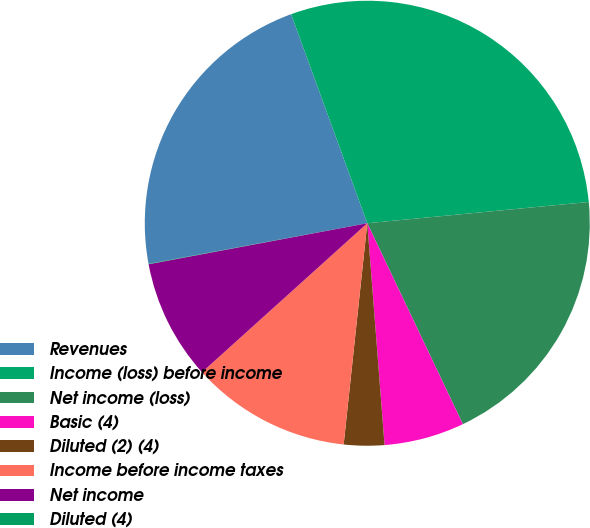Convert chart. <chart><loc_0><loc_0><loc_500><loc_500><pie_chart><fcel>Revenues<fcel>Income (loss) before income<fcel>Net income (loss)<fcel>Basic (4)<fcel>Diluted (2) (4)<fcel>Income before income taxes<fcel>Net income<fcel>Diluted (4)<nl><fcel>22.36%<fcel>29.04%<fcel>19.46%<fcel>5.83%<fcel>2.93%<fcel>11.63%<fcel>8.73%<fcel>0.03%<nl></chart> 